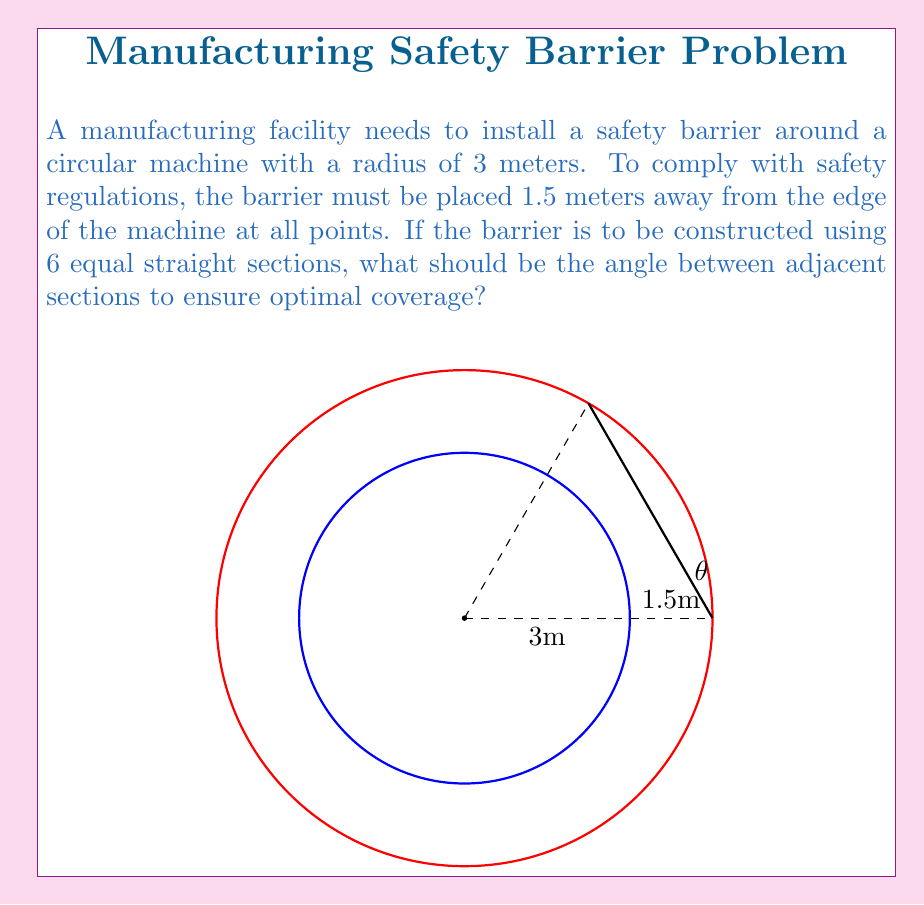Teach me how to tackle this problem. Let's approach this step-by-step:

1) The barrier forms a larger circle around the machine. Its radius is:
   $R = 3 \text{ m} + 1.5 \text{ m} = 4.5 \text{ m}$

2) The barrier is to be constructed using 6 equal straight sections. This means the circle will be divided into 6 equal parts.

3) In a circle, the central angle that subtends an arc is twice the inscribed angle that subtends the same arc. Here, we're interested in the central angle.

4) For a complete circle, the central angle is 360°. For 6 equal parts:
   $\theta = \frac{360°}{6} = 60°$

5) To confirm this is correct, we can calculate the length of each straight section:
   Chord length = $2R \sin(\frac{\theta}{2}) = 2 \cdot 4.5 \cdot \sin(30°) = 4.5 \text{ m}$

6) The perimeter of the hexagon formed by these 6 sections:
   $6 \cdot 4.5 = 27 \text{ m}$

7) This is slightly less than the circumference of the circle $(2\pi R = 2\pi \cdot 4.5 \approx 28.27 \text{ m})$, which is expected as the hexagon inscribes the circle.

Therefore, the optimal angle between adjacent sections is 60°.
Answer: 60° 